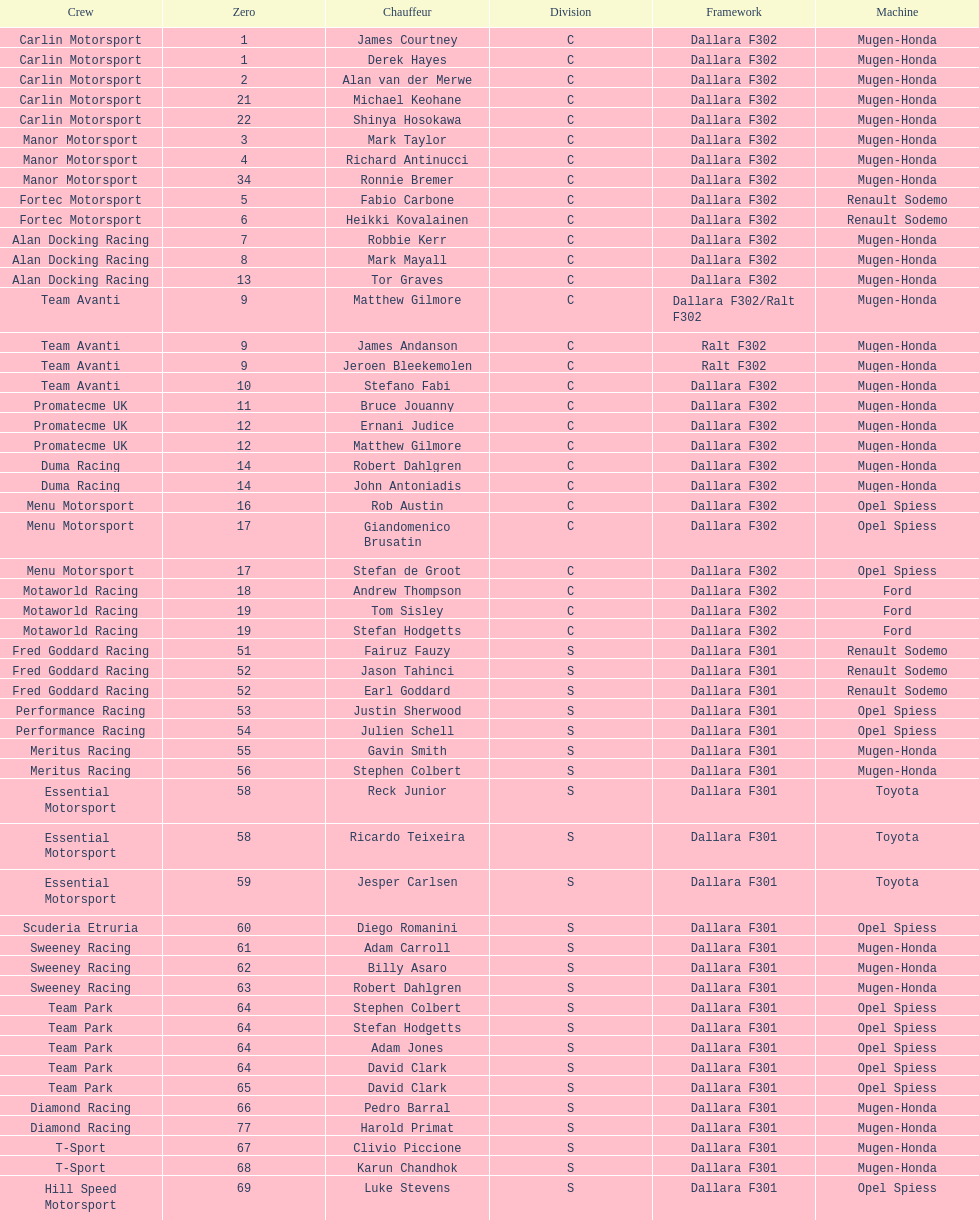What is the number of teams that had drivers all from the same country? 4. 